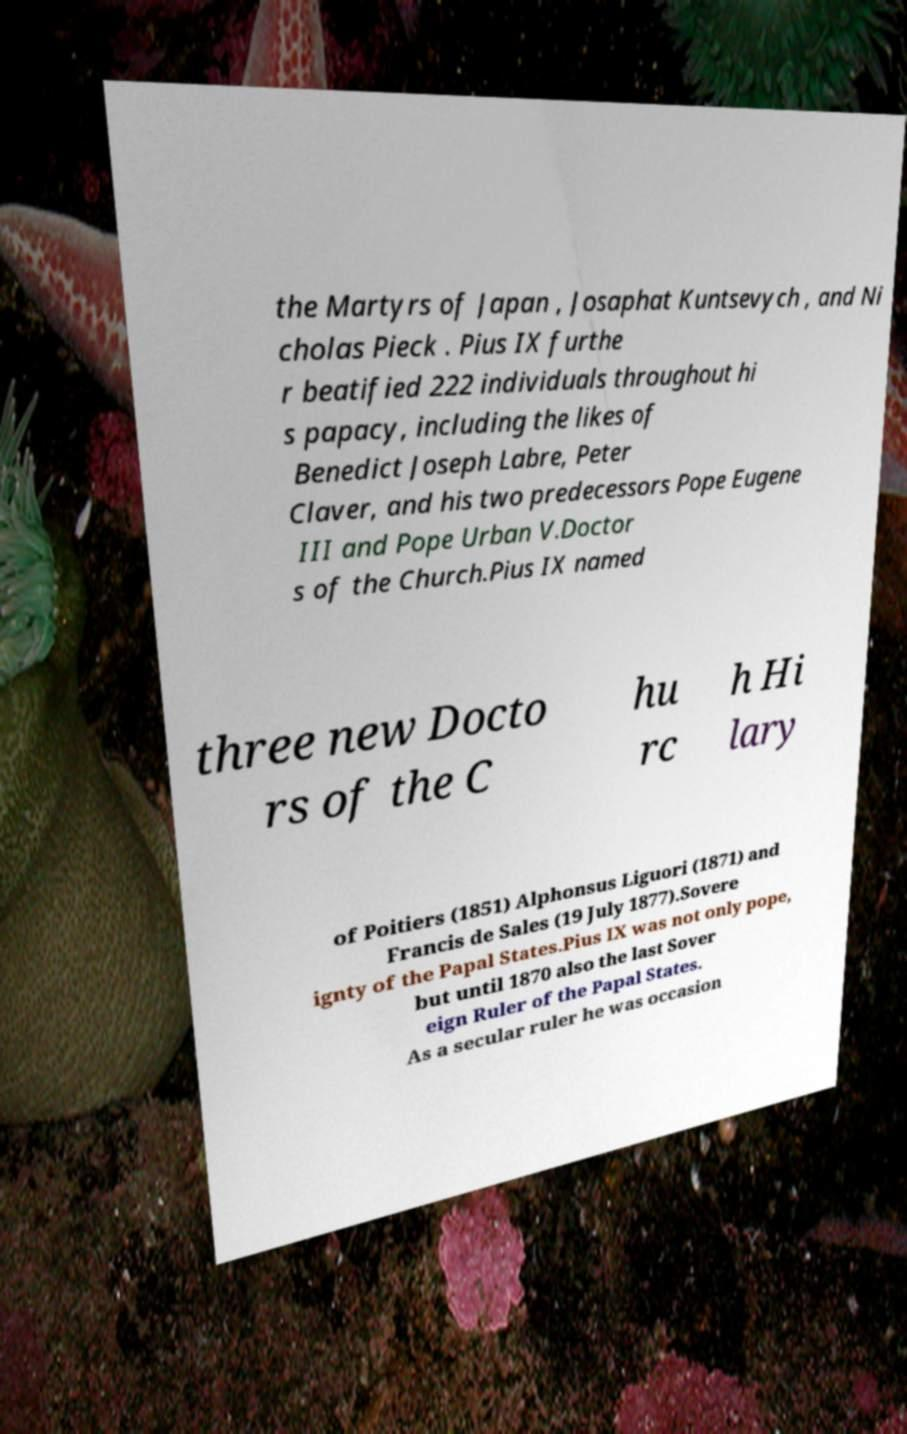Could you assist in decoding the text presented in this image and type it out clearly? the Martyrs of Japan , Josaphat Kuntsevych , and Ni cholas Pieck . Pius IX furthe r beatified 222 individuals throughout hi s papacy, including the likes of Benedict Joseph Labre, Peter Claver, and his two predecessors Pope Eugene III and Pope Urban V.Doctor s of the Church.Pius IX named three new Docto rs of the C hu rc h Hi lary of Poitiers (1851) Alphonsus Liguori (1871) and Francis de Sales (19 July 1877).Sovere ignty of the Papal States.Pius IX was not only pope, but until 1870 also the last Sover eign Ruler of the Papal States. As a secular ruler he was occasion 